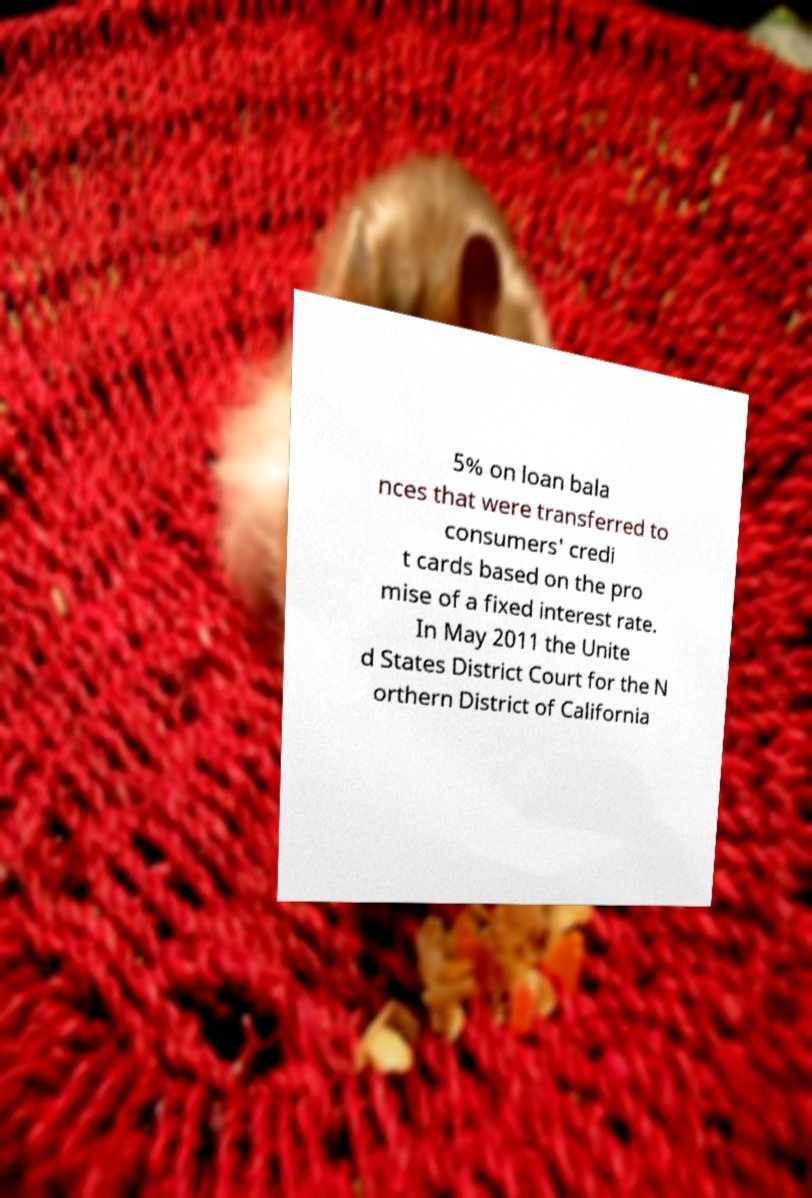For documentation purposes, I need the text within this image transcribed. Could you provide that? 5% on loan bala nces that were transferred to consumers' credi t cards based on the pro mise of a fixed interest rate. In May 2011 the Unite d States District Court for the N orthern District of California 